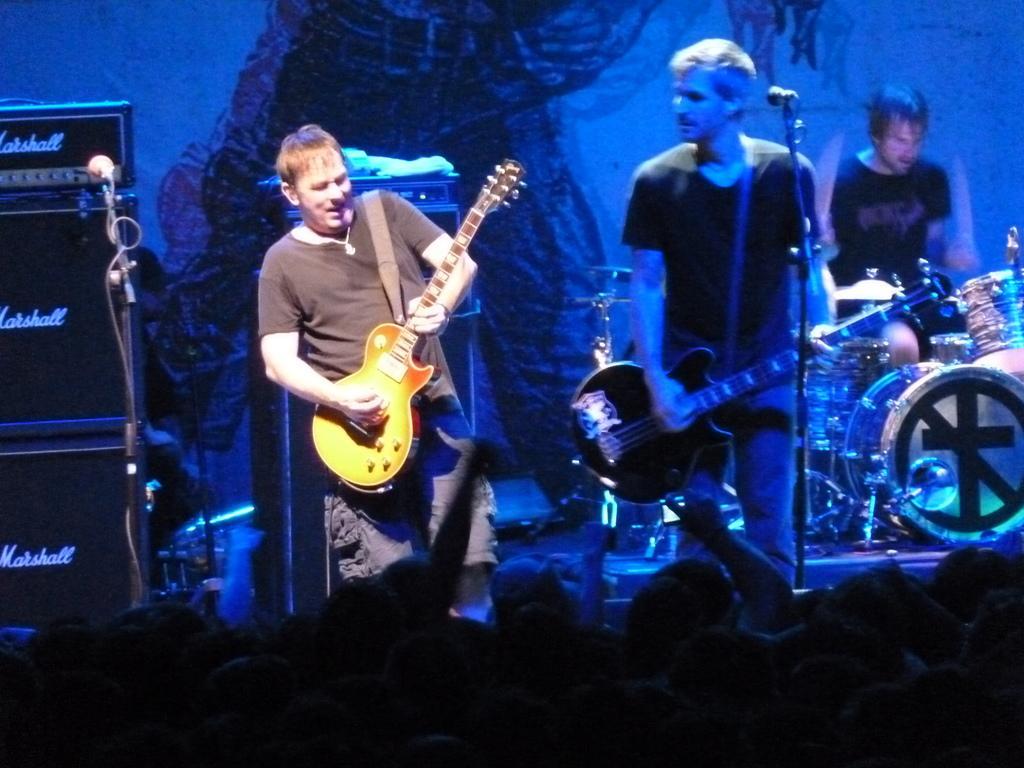How would you summarize this image in a sentence or two? There is a group of people. They are standing on a stage. They are playing a musical instruments. We can see in background blue color curtain and microphone. 